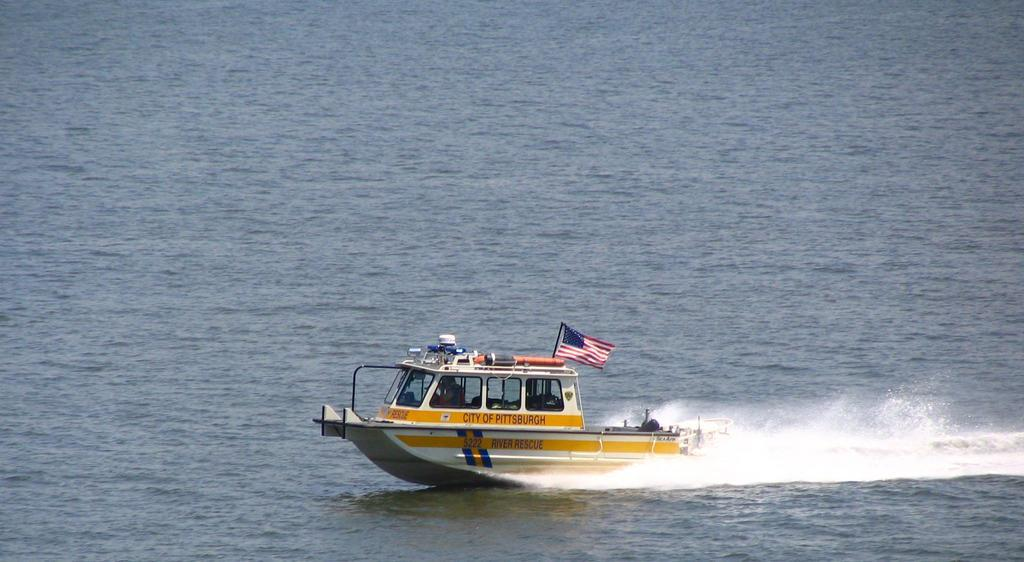What is the person in the image doing? There is a person sailing a boat in the image. Where is the boat located? The boat is on the water. What can be seen in the middle of the image? There is a pole with a flag in the middle of the image. How does the cannon roll in the image? There is no cannon present in the image, so it cannot roll. 